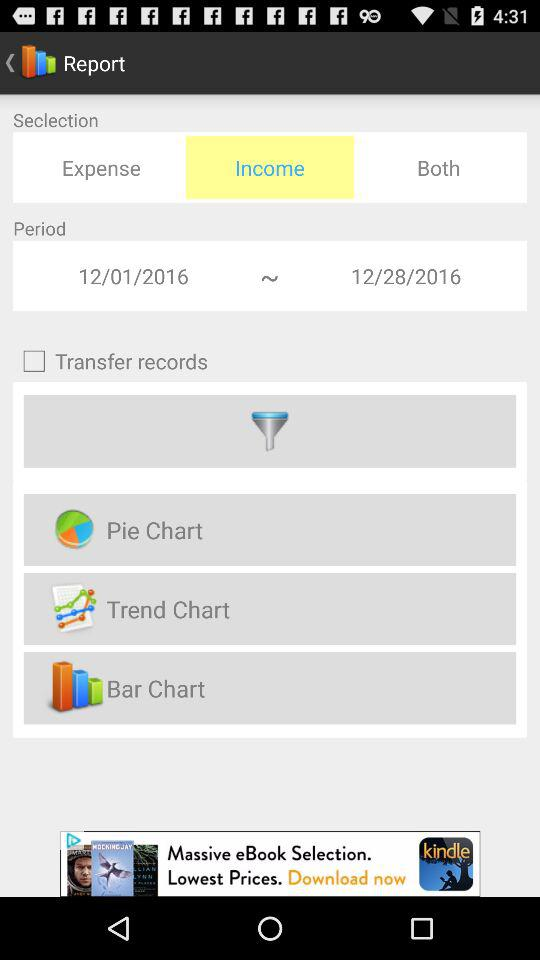Which selection is selected? The income section is selected. 